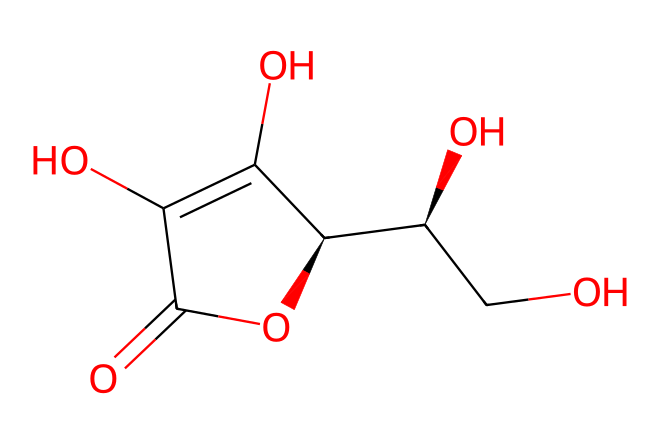How many carbon atoms are in the structure? By examining the SMILES representation, we count the carbon atoms denoted by 'C'. There are 6 carbon atoms in total within the structure when mapped.
Answer: 6 What is the main functional group present in vitamin C? The structure includes multiple -OH (hydroxyl) groups, which are characteristic of alcohols, but the defining feature of vitamin C is the lactone (cyclic ester) formed in the structure.
Answer: lactone How many double bonds are in this chemical structure? Analyzing the SMILES, we see that there is one double bond indicated by the '=' sign between carbon and oxygen.
Answer: 1 What type of antioxidant is vitamin C considered? Vitamin C is known as a water-soluble antioxidant, primarily due to its ability to dissolve in water and its biological function in scavenging free radicals.
Answer: water-soluble What is the molecular formula of vitamin C derived from the structure? The breakdown of the SMILES into the individual atoms gives a total count of 6 carbons, 8 hydrogens, and 6 oxygens, leading to the molecular formula C6H8O6.
Answer: C6H8O6 How does vitamin C protect against oxidative stress? Vitamin C donates electrons to free radicals, neutralizing them and thus protecting cells from damage. This action is supported by the hydroxyl groups in its structure emphasizing its reducing properties.
Answer: donates electrons 